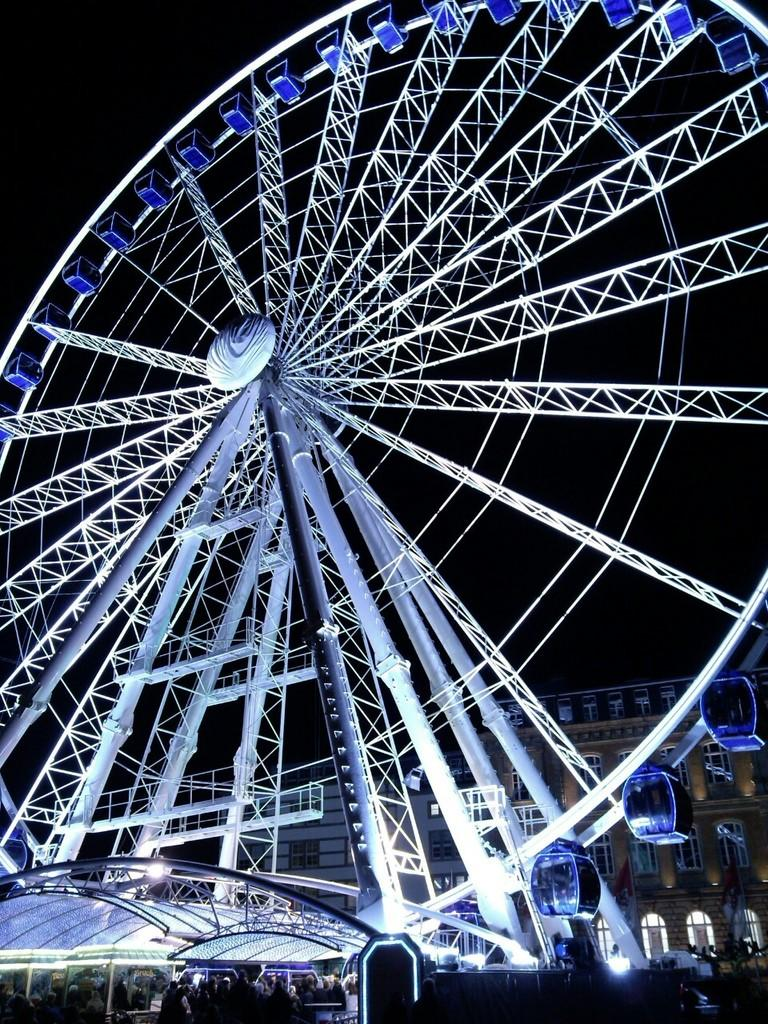What type of wheel is shown in the image? There is a joint wheel in the image. What structure can be seen in the image? There is a shelter in the image. Who or what is present in the image? There are people in the image. What type of buildings are visible in the image? There are buildings with windows in the image. Can you describe any other objects in the image? There are other objects in the image, but their specific details are not mentioned in the provided facts. What is the color of the background in the image? The background of the image is dark. How many turkeys can be seen in the image? There are no turkeys present in the image. 